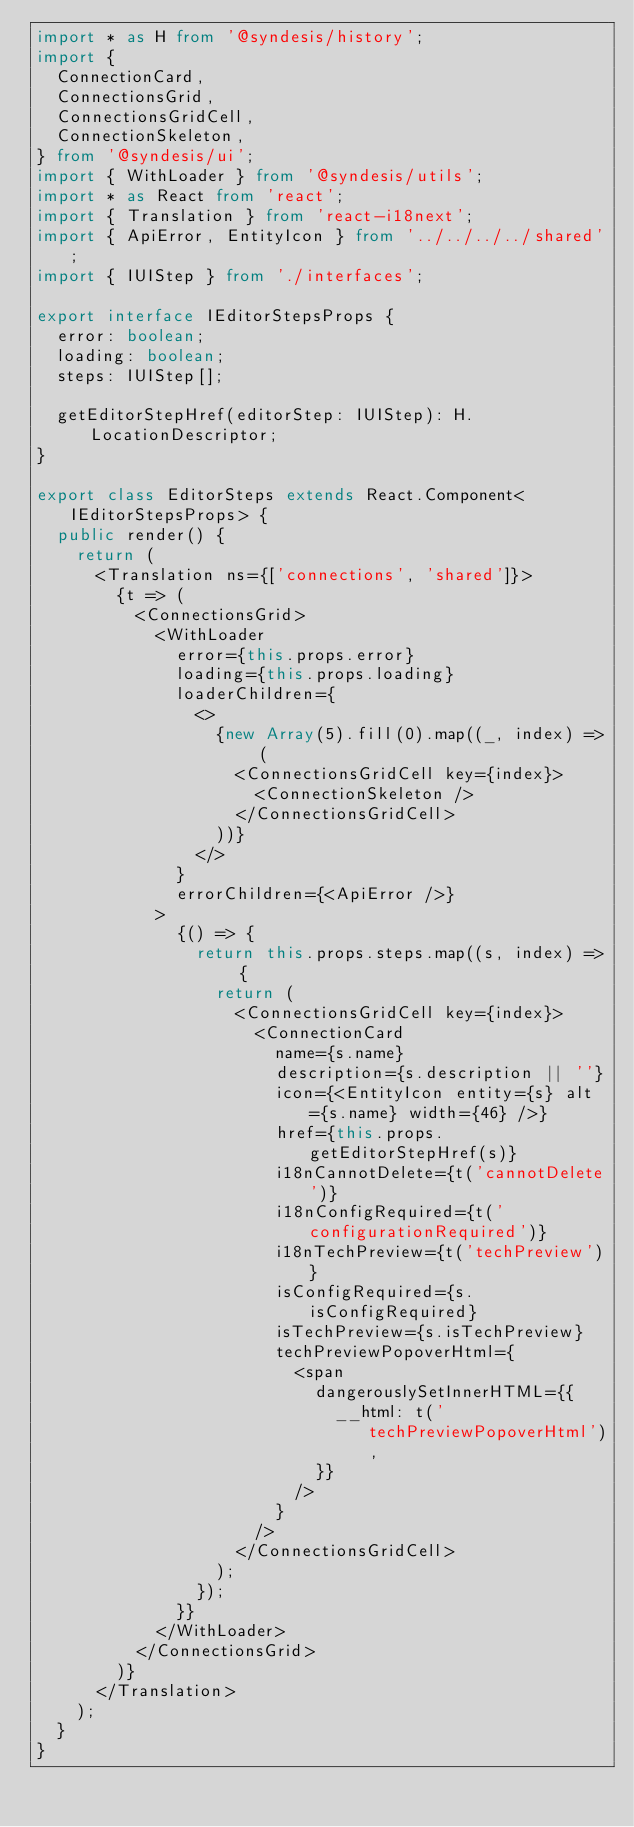Convert code to text. <code><loc_0><loc_0><loc_500><loc_500><_TypeScript_>import * as H from '@syndesis/history';
import {
  ConnectionCard,
  ConnectionsGrid,
  ConnectionsGridCell,
  ConnectionSkeleton,
} from '@syndesis/ui';
import { WithLoader } from '@syndesis/utils';
import * as React from 'react';
import { Translation } from 'react-i18next';
import { ApiError, EntityIcon } from '../../../../shared';
import { IUIStep } from './interfaces';

export interface IEditorStepsProps {
  error: boolean;
  loading: boolean;
  steps: IUIStep[];

  getEditorStepHref(editorStep: IUIStep): H.LocationDescriptor;
}

export class EditorSteps extends React.Component<IEditorStepsProps> {
  public render() {
    return (
      <Translation ns={['connections', 'shared']}>
        {t => (
          <ConnectionsGrid>
            <WithLoader
              error={this.props.error}
              loading={this.props.loading}
              loaderChildren={
                <>
                  {new Array(5).fill(0).map((_, index) => (
                    <ConnectionsGridCell key={index}>
                      <ConnectionSkeleton />
                    </ConnectionsGridCell>
                  ))}
                </>
              }
              errorChildren={<ApiError />}
            >
              {() => {
                return this.props.steps.map((s, index) => {
                  return (
                    <ConnectionsGridCell key={index}>
                      <ConnectionCard
                        name={s.name}
                        description={s.description || ''}
                        icon={<EntityIcon entity={s} alt={s.name} width={46} />}
                        href={this.props.getEditorStepHref(s)}
                        i18nCannotDelete={t('cannotDelete')}
                        i18nConfigRequired={t('configurationRequired')}
                        i18nTechPreview={t('techPreview')}
                        isConfigRequired={s.isConfigRequired}
                        isTechPreview={s.isTechPreview}
                        techPreviewPopoverHtml={
                          <span
                            dangerouslySetInnerHTML={{
                              __html: t('techPreviewPopoverHtml'),
                            }}
                          />
                        }
                      />
                    </ConnectionsGridCell>
                  );
                });
              }}
            </WithLoader>
          </ConnectionsGrid>
        )}
      </Translation>
    );
  }
}
</code> 